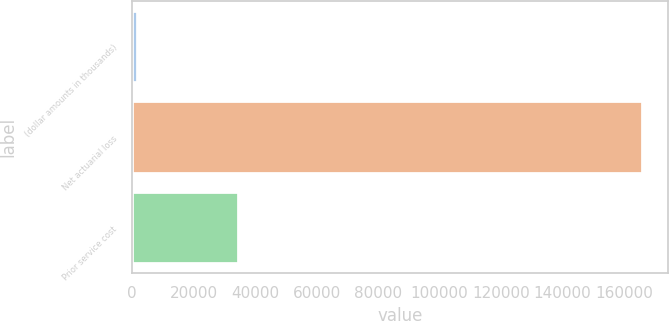Convert chart. <chart><loc_0><loc_0><loc_500><loc_500><bar_chart><fcel>(dollar amounts in thousands)<fcel>Net actuarial loss<fcel>Prior service cost<nl><fcel>2010<fcel>166183<fcel>34688<nl></chart> 